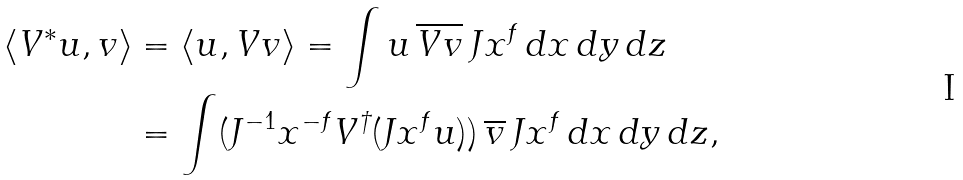Convert formula to latex. <formula><loc_0><loc_0><loc_500><loc_500>\langle V ^ { * } u , v \rangle & = \langle u , V v \rangle = \int u \, \overline { V v } \, J x ^ { f } \, d x \, d y \, d z \\ & = \int ( J ^ { - 1 } x ^ { - f } V ^ { \dagger } ( J x ^ { f } u ) ) \, \overline { v } \, J x ^ { f } \, d x \, d y \, d z ,</formula> 